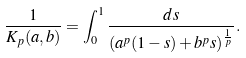Convert formula to latex. <formula><loc_0><loc_0><loc_500><loc_500>\frac { 1 } { K _ { p } ( a , b ) } = \int _ { 0 } ^ { 1 } \frac { d s } { ( a ^ { p } ( 1 - s ) + b ^ { p } s ) ^ { \frac { 1 } { p } } } .</formula> 